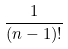Convert formula to latex. <formula><loc_0><loc_0><loc_500><loc_500>\frac { 1 } { ( n - 1 ) ! }</formula> 